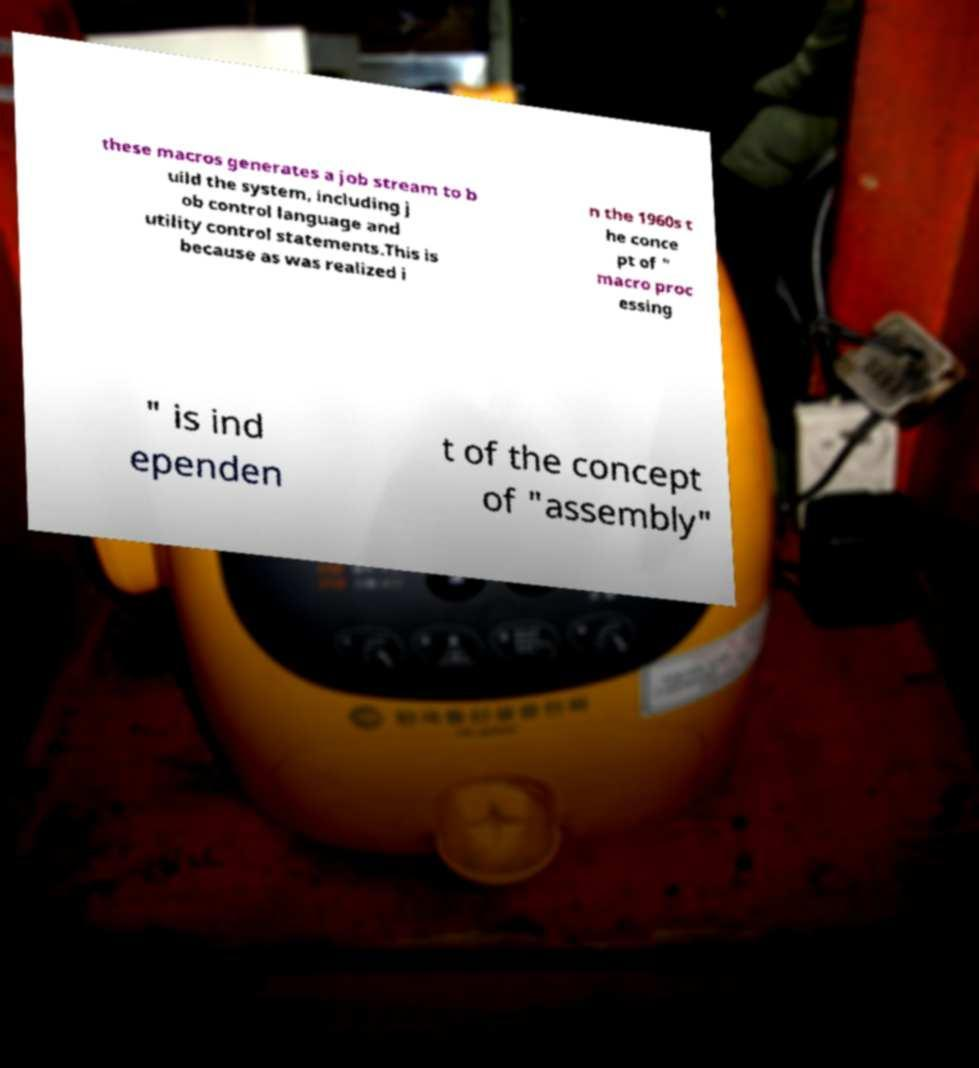Could you extract and type out the text from this image? these macros generates a job stream to b uild the system, including j ob control language and utility control statements.This is because as was realized i n the 1960s t he conce pt of " macro proc essing " is ind ependen t of the concept of "assembly" 